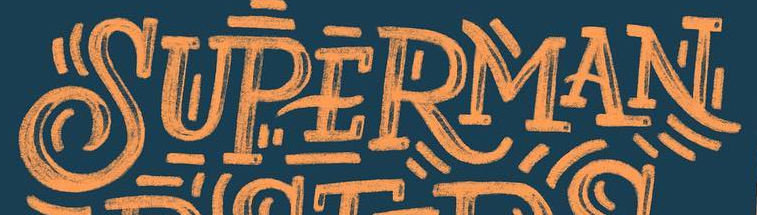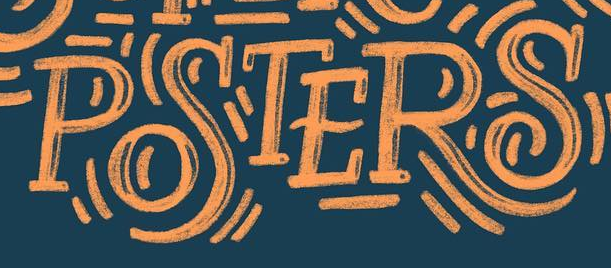Read the text content from these images in order, separated by a semicolon. SUPERMAN; POSTERS 